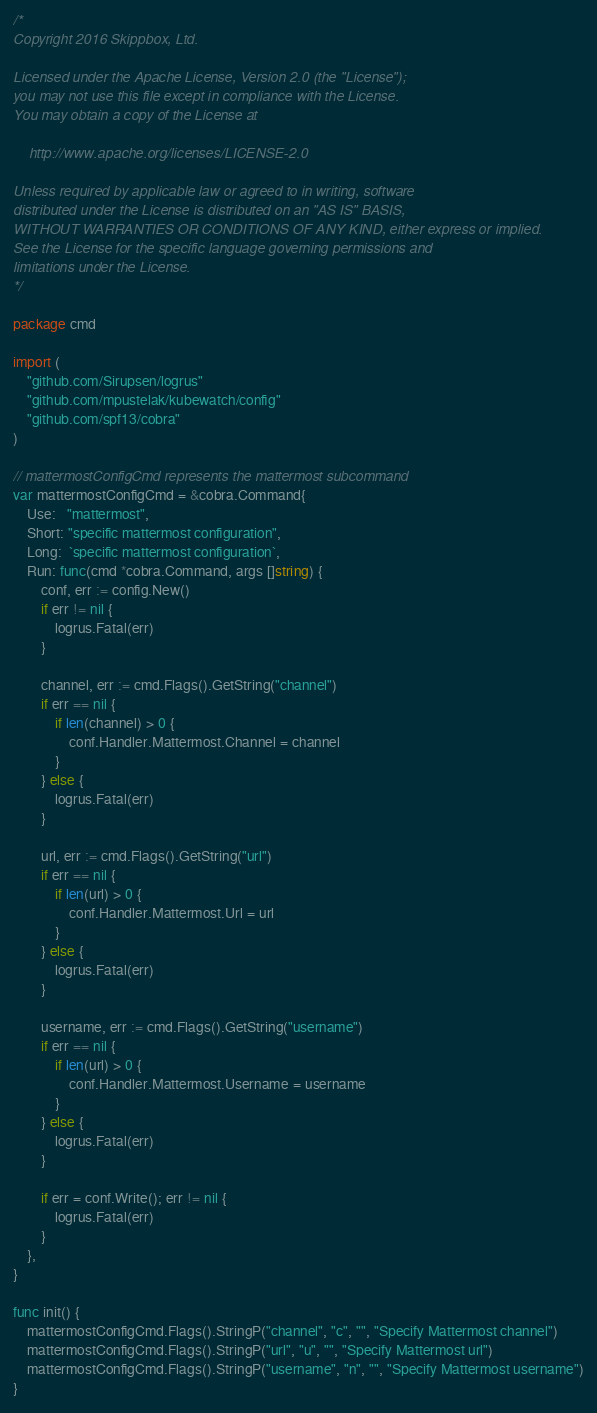Convert code to text. <code><loc_0><loc_0><loc_500><loc_500><_Go_>/*
Copyright 2016 Skippbox, Ltd.

Licensed under the Apache License, Version 2.0 (the "License");
you may not use this file except in compliance with the License.
You may obtain a copy of the License at

    http://www.apache.org/licenses/LICENSE-2.0

Unless required by applicable law or agreed to in writing, software
distributed under the License is distributed on an "AS IS" BASIS,
WITHOUT WARRANTIES OR CONDITIONS OF ANY KIND, either express or implied.
See the License for the specific language governing permissions and
limitations under the License.
*/

package cmd

import (
	"github.com/Sirupsen/logrus"
	"github.com/mpustelak/kubewatch/config"
	"github.com/spf13/cobra"
)

// mattermostConfigCmd represents the mattermost subcommand
var mattermostConfigCmd = &cobra.Command{
	Use:   "mattermost",
	Short: "specific mattermost configuration",
	Long:  `specific mattermost configuration`,
	Run: func(cmd *cobra.Command, args []string) {
		conf, err := config.New()
		if err != nil {
			logrus.Fatal(err)
		}

		channel, err := cmd.Flags().GetString("channel")
		if err == nil {
			if len(channel) > 0 {
				conf.Handler.Mattermost.Channel = channel
			}
		} else {
			logrus.Fatal(err)
		}

		url, err := cmd.Flags().GetString("url")
		if err == nil {
			if len(url) > 0 {
				conf.Handler.Mattermost.Url = url
			}
		} else {
			logrus.Fatal(err)
		}

		username, err := cmd.Flags().GetString("username")
		if err == nil {
			if len(url) > 0 {
				conf.Handler.Mattermost.Username = username
			}
		} else {
			logrus.Fatal(err)
		}

		if err = conf.Write(); err != nil {
			logrus.Fatal(err)
		}
	},
}

func init() {
	mattermostConfigCmd.Flags().StringP("channel", "c", "", "Specify Mattermost channel")
	mattermostConfigCmd.Flags().StringP("url", "u", "", "Specify Mattermost url")
	mattermostConfigCmd.Flags().StringP("username", "n", "", "Specify Mattermost username")
}
</code> 